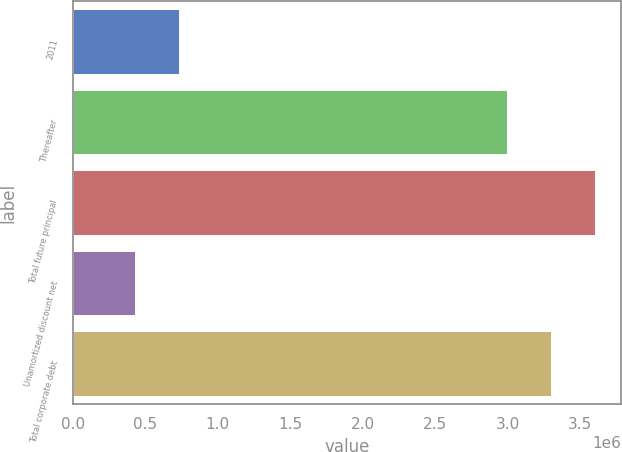<chart> <loc_0><loc_0><loc_500><loc_500><bar_chart><fcel>2011<fcel>Thereafter<fcel>Total future principal<fcel>Unamortized discount net<fcel>Total corporate debt<nl><fcel>729724<fcel>2.99634e+06<fcel>3.60088e+06<fcel>427454<fcel>3.29861e+06<nl></chart> 